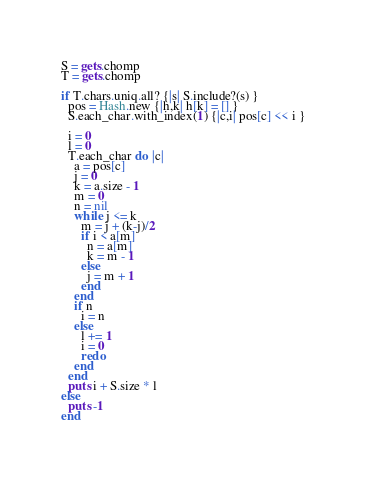Convert code to text. <code><loc_0><loc_0><loc_500><loc_500><_Ruby_>S = gets.chomp
T = gets.chomp

if T.chars.uniq.all? {|s| S.include?(s) }
  pos = Hash.new {|h,k| h[k] = [] }
  S.each_char.with_index(1) {|c,i| pos[c] << i }

  i = 0
  l = 0
  T.each_char do |c|
    a = pos[c]
    j = 0
    k = a.size - 1
    m = 0
    n = nil
    while j <= k
      m = j + (k-j)/2
      if i < a[m]
        n = a[m]
        k = m - 1
      else
        j = m + 1
      end
    end
    if n
      i = n
    else
      l += 1
      i = 0
      redo
    end
  end
  puts i + S.size * l
else
  puts -1
end
</code> 